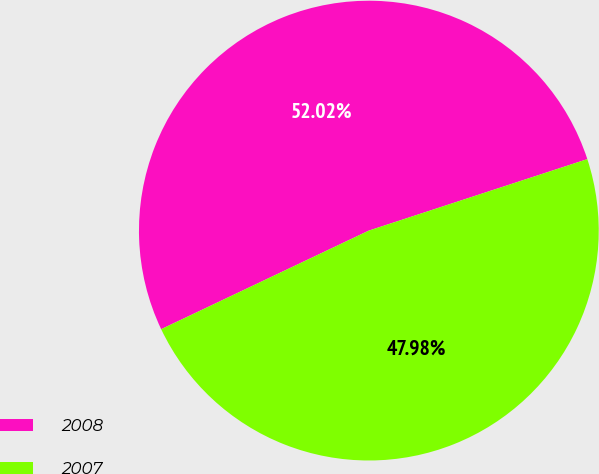<chart> <loc_0><loc_0><loc_500><loc_500><pie_chart><fcel>2008<fcel>2007<nl><fcel>52.02%<fcel>47.98%<nl></chart> 